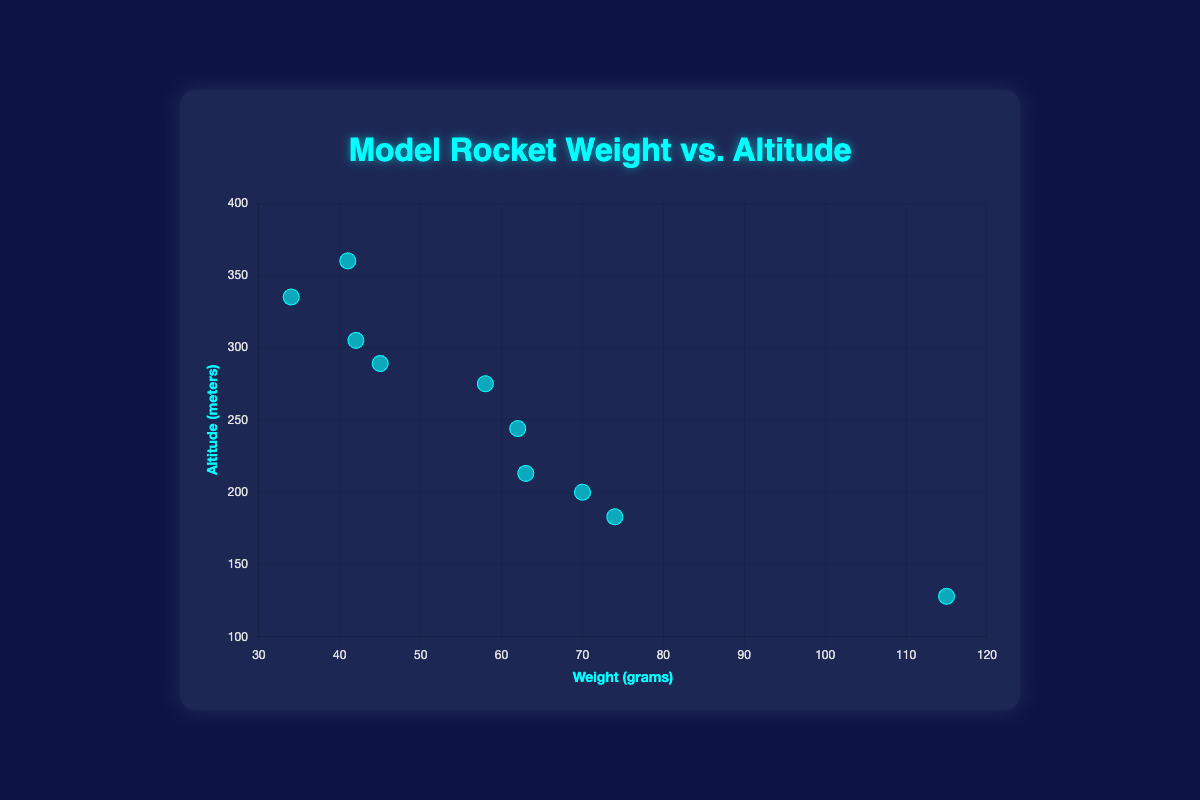How many data points are there in the figure? By counting each labeled data point (model rocket) in the scatter plot, we can determine the total number of data points. There are 10 model rockets represented.
Answer: 10 What are the labels for the x and y axes? The x-axis is labeled 'Weight (grams)' and the y-axis is labeled 'Altitude (meters),' as indicated by the titles next to each axis.
Answer: Weight (grams) and Altitude (meters) Which model rocket achieves the highest altitude? By examining the y-values of all data points, the Quest Aerospace Astra III reaches the highest altitude at 360 meters.
Answer: Quest Aerospace Astra III Which model rocket has the highest weight? By examining the x-values of all data points, the Estes SNS US Army Patriot has the highest weight at 115 grams.
Answer: Estes SNS US Army Patriot What is the altitude and weight of the Estes Viking? The position of the Estes Viking on the scatter plot shows a weight of 34 grams and an altitude of 335 meters.
Answer: 34 grams, 335 meters Which model rocket is both the lightest and reaches an altitude above 300 meters? By looking at the x-values for weight and checking y-values for altitude above 300 meters, the Estes Viking at 34 grams and 335 meters is the lightest among those reaching over 300 meters.
Answer: Estes Viking What is the average altitude reached by all model rockets shown? Summing the altitudes (305 + 183 + 289 + 335 + 213 + 128 + 360 + 244 + 275 + 200) equals 2532. Dividing by the number of rockets (10) gives the average altitude of 2532/10 = 253.2 meters.
Answer: 253.2 meters Which two model rockets have the closest altitudes, and what are their altitudes? By comparing the differences between the y-values, the next closest altitudes are 289 meters (Estes Astra) and 275 meters (Semroc Model Rocket Blue Bird Zero), with a small difference of 289 - 275 = 14 meters.
Answer: Estes Astra and Semroc Model Rocket Blue Bird Zero, with 289 meters and 275 meters respectively Is there a general trend between weight and altitude? By observing the scatter plot, it appears that there is an inverse relationship; lighter model rockets generally reach higher altitudes. This trend is indicative of a negative correlation between weight and altitude.
Answer: Negative correlation 